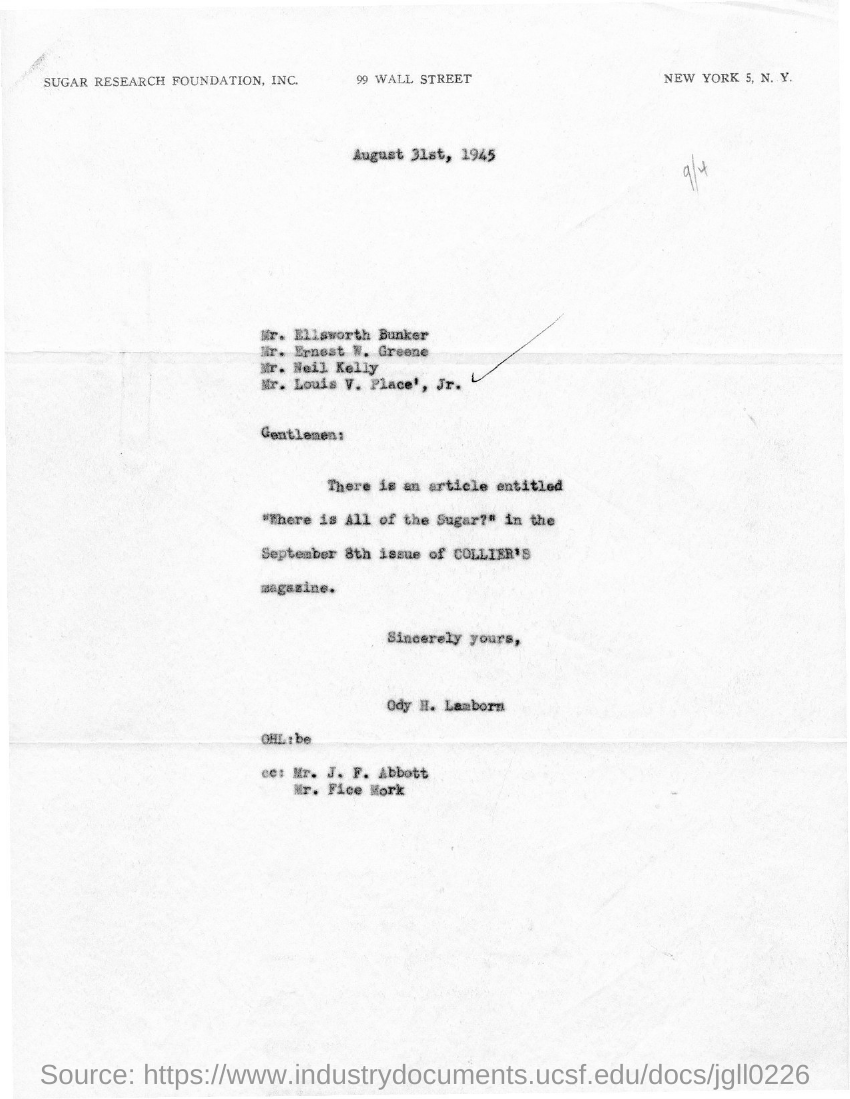Who is the sender of this letter?
Give a very brief answer. Ody H. Lamborn. What is this letter dated?
Make the answer very short. August 31st, 1945. 